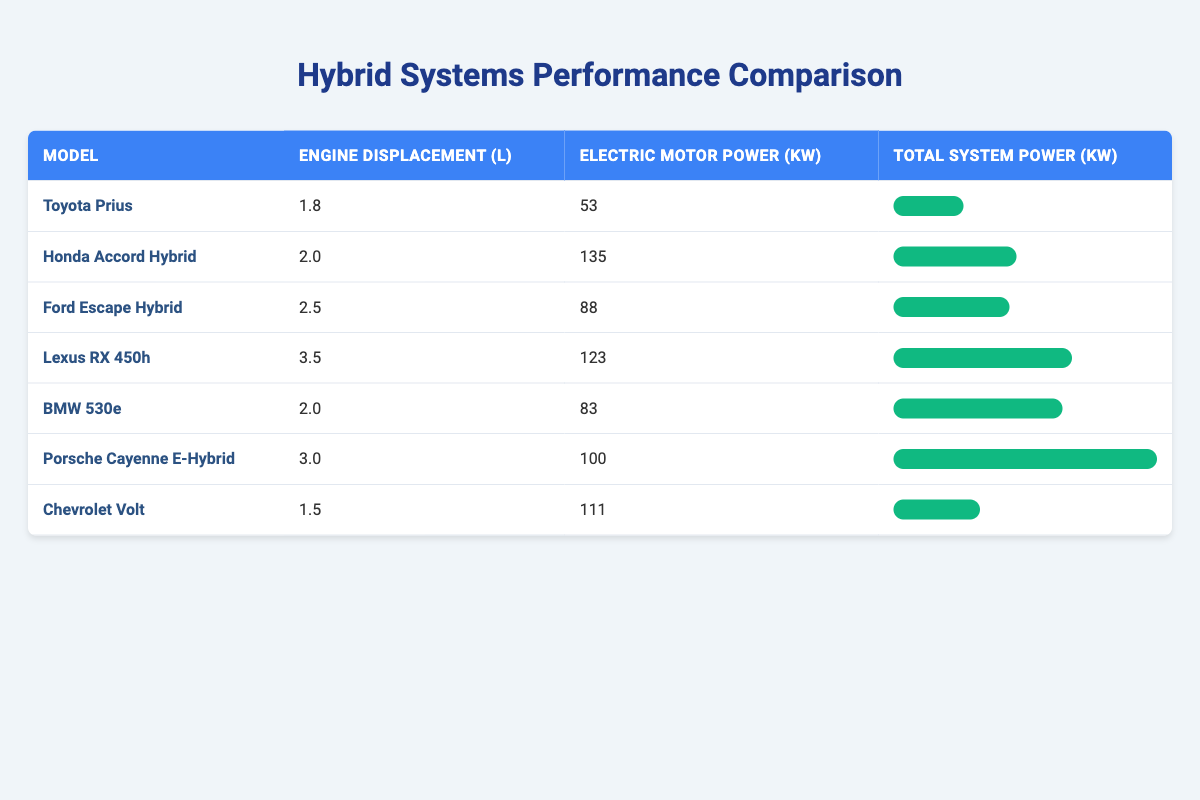What is the engine displacement of the Toyota Prius? According to the table, the engine displacement of the Toyota Prius is listed under the "Engine Displacement (L)" column, which shows a value of 1.8 liters.
Answer: 1.8 liters Which hybrid system has the highest total system power? Looking at the "Total System Power (kW)" column, the maximum value is 455 kW, which corresponds to the Porsche Cayenne E-Hybrid.
Answer: Porsche Cayenne E-Hybrid What is the average electric motor power of the hybrid systems listed in the table? To find the average electric motor power, sum the electric motor power values: 53 + 135 + 88 + 123 + 83 + 100 + 111 = 693 kW. There are 7 models, so the average is 693/7 = 99 kW.
Answer: 99 kW Does the Ford Escape Hybrid have a higher total system power than the Chevrolet Volt? The total system power for the Ford Escape Hybrid is 200 kW, and for the Chevrolet Volt, it is 149 kW, which means that the Ford Escape Hybrid has a higher total system power.
Answer: Yes Which hybrid system has the lowest engine displacement and how much is it? The table shows that the hybrid system with the lowest engine displacement is the Chevrolet Volt, with an engine displacement of 1.5 liters.
Answer: Chevrolet Volt, 1.5 liters What is the difference in total system power between the Lexus RX 450h and the Honda Accord Hybrid? The total system power for the Lexus RX 450h is 308 kW, while for the Honda Accord Hybrid, it is 212 kW. The difference is 308 - 212 = 96 kW.
Answer: 96 kW Is the electric motor power of the BMW 530e greater than that of the Toyota Prius? The electric motor power of the BMW 530e is 83 kW, and the power of the Toyota Prius is 53 kW. Since 83 > 53, this statement is true.
Answer: Yes What percentage of total system power does the electric motor contribute for the Lexus RX 450h? For the Lexus RX 450h, the total power is 308 kW and the electric motor power is 123 kW. To find the percentage contribution, divide 123 by 308 and multiply by 100, yielding (123/308) * 100 ≈ 39.94%.
Answer: Approximately 39.94% 